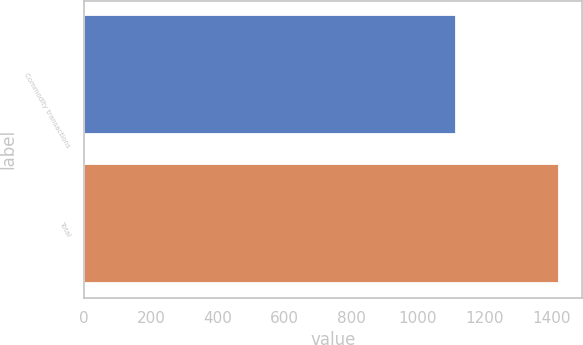Convert chart. <chart><loc_0><loc_0><loc_500><loc_500><bar_chart><fcel>Commodity transactions<fcel>Total<nl><fcel>1114<fcel>1423<nl></chart> 